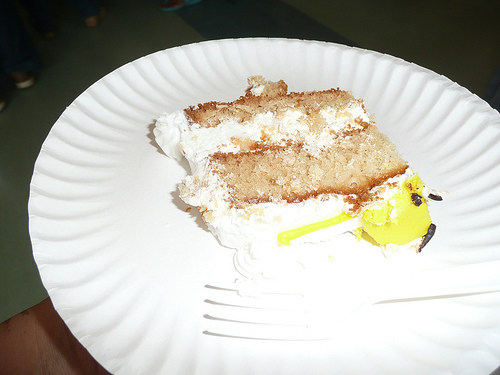<image>
Can you confirm if the cake is on the table? Yes. Looking at the image, I can see the cake is positioned on top of the table, with the table providing support. Where is the cake in relation to the plate? Is it on the plate? Yes. Looking at the image, I can see the cake is positioned on top of the plate, with the plate providing support. 